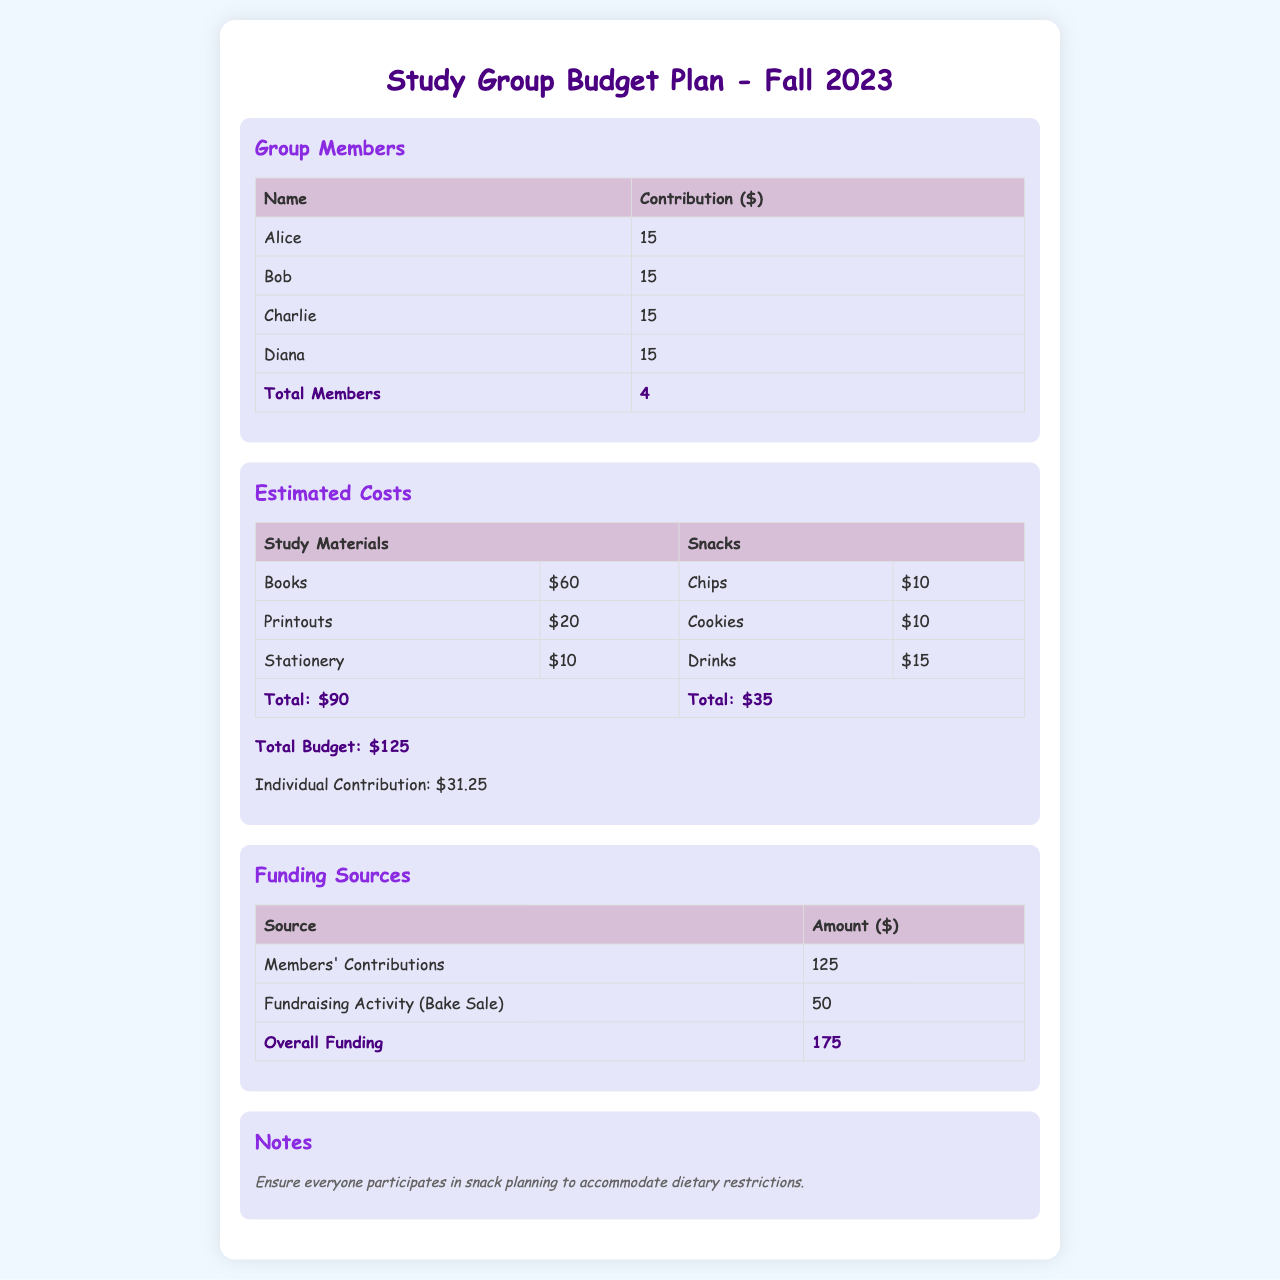What is the total number of group members? The total number of group members is provided in the table under "Group Members".
Answer: 4 How much does each member contribute? Each member's contribution is listed in the "Group Members" section.
Answer: 15 What is the total estimated cost for study materials? The total cost for study materials is the sum of individual items listed under "Estimated Costs".
Answer: 90 What is the total budget for snacks? The total budget for snacks is listed at the end of the snacks cost section.
Answer: 35 How much is the overall funding? The overall funding is calculated from all funding sources in the "Funding Sources" section.
Answer: 175 What is the individual contribution required from each member? The individual contribution is calculated based on the total budget and the number of members.
Answer: 31.25 Which fundraising activity is mentioned? The "Funding Sources" section includes a specific fundraising activity that contributes to the budget.
Answer: Bake Sale What is the note about dietary restrictions? The note emphasizes the importance of participation in snack planning with respect to dietary needs.
Answer: Ensure everyone participates in snack planning to accommodate dietary restrictions 